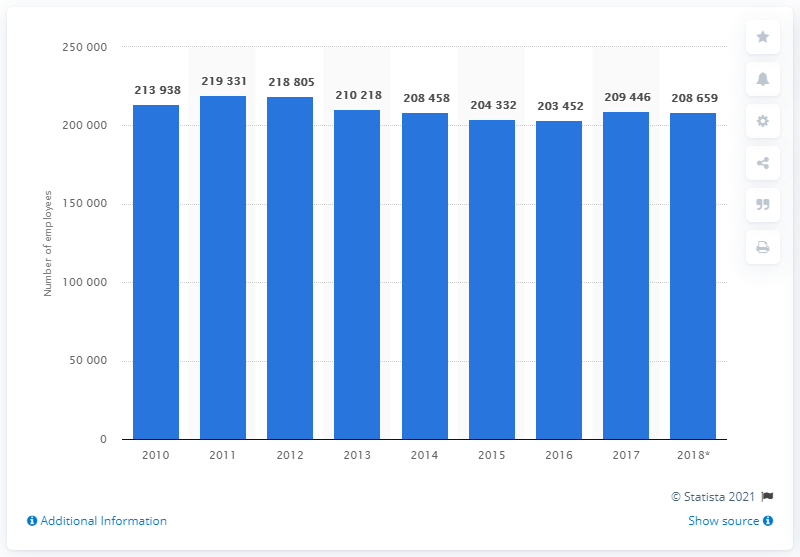Draw attention to some important aspects in this diagram. In 2017, there were approximately 208,659 employees working in the construction industry in Belgium. 